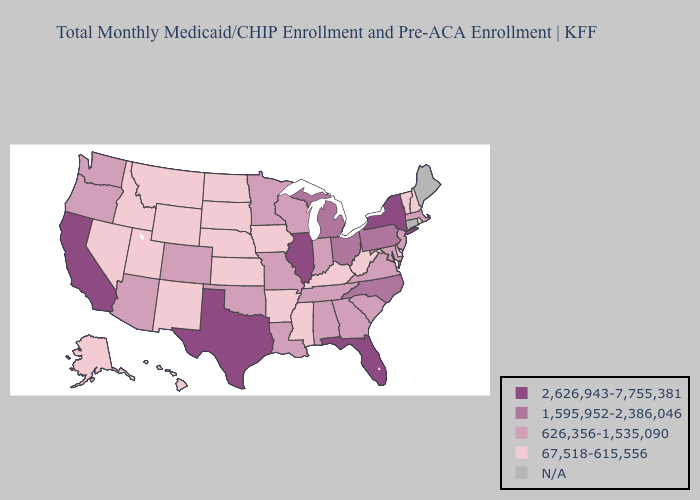Among the states that border Missouri , which have the lowest value?
Keep it brief. Arkansas, Iowa, Kansas, Kentucky, Nebraska. Which states have the lowest value in the South?
Answer briefly. Arkansas, Delaware, Kentucky, Mississippi, West Virginia. Name the states that have a value in the range 2,626,943-7,755,381?
Quick response, please. California, Florida, Illinois, New York, Texas. What is the lowest value in states that border Utah?
Answer briefly. 67,518-615,556. What is the highest value in states that border Washington?
Concise answer only. 626,356-1,535,090. What is the value of South Carolina?
Concise answer only. 626,356-1,535,090. Which states have the lowest value in the West?
Keep it brief. Alaska, Hawaii, Idaho, Montana, Nevada, New Mexico, Utah, Wyoming. What is the value of Wisconsin?
Concise answer only. 626,356-1,535,090. Name the states that have a value in the range 2,626,943-7,755,381?
Keep it brief. California, Florida, Illinois, New York, Texas. Does Minnesota have the lowest value in the USA?
Quick response, please. No. Does the first symbol in the legend represent the smallest category?
Write a very short answer. No. Is the legend a continuous bar?
Keep it brief. No. Which states have the lowest value in the USA?
Keep it brief. Alaska, Arkansas, Delaware, Hawaii, Idaho, Iowa, Kansas, Kentucky, Mississippi, Montana, Nebraska, Nevada, New Hampshire, New Mexico, North Dakota, Rhode Island, South Dakota, Utah, Vermont, West Virginia, Wyoming. 